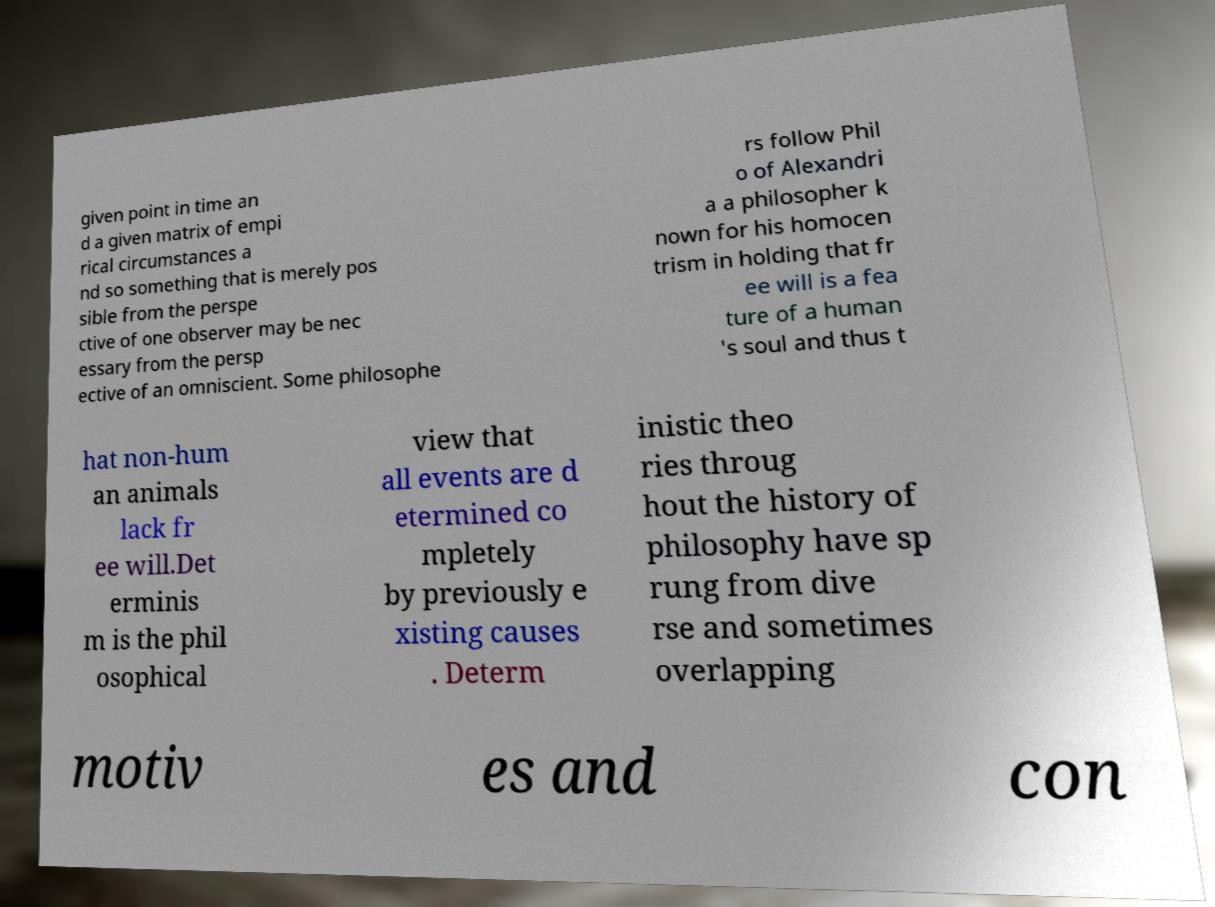Please identify and transcribe the text found in this image. given point in time an d a given matrix of empi rical circumstances a nd so something that is merely pos sible from the perspe ctive of one observer may be nec essary from the persp ective of an omniscient. Some philosophe rs follow Phil o of Alexandri a a philosopher k nown for his homocen trism in holding that fr ee will is a fea ture of a human 's soul and thus t hat non-hum an animals lack fr ee will.Det erminis m is the phil osophical view that all events are d etermined co mpletely by previously e xisting causes . Determ inistic theo ries throug hout the history of philosophy have sp rung from dive rse and sometimes overlapping motiv es and con 